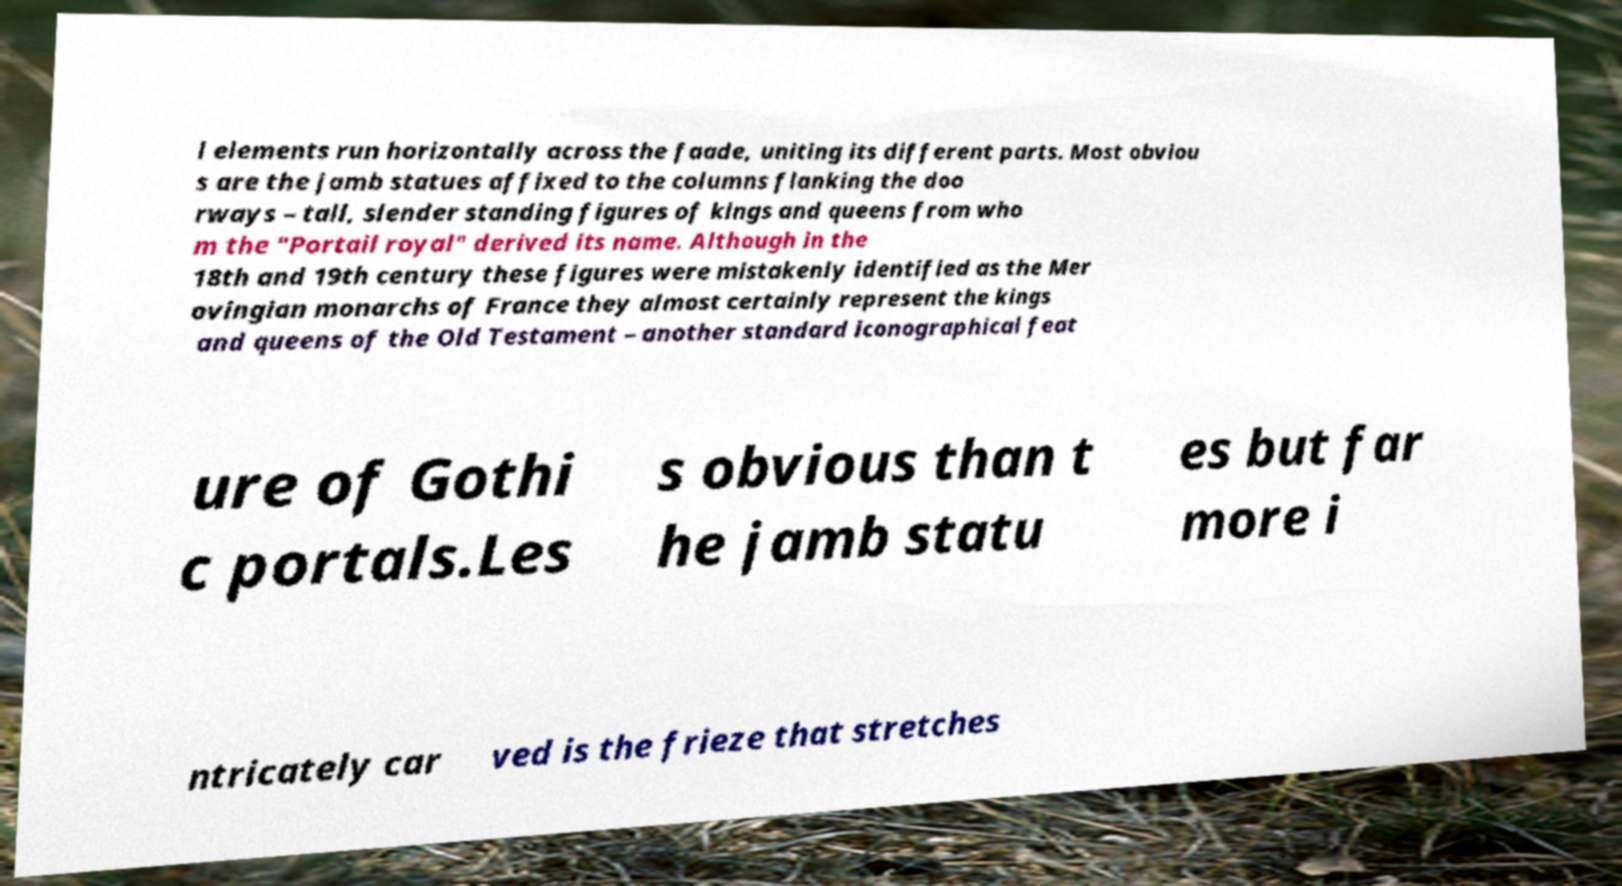Can you accurately transcribe the text from the provided image for me? l elements run horizontally across the faade, uniting its different parts. Most obviou s are the jamb statues affixed to the columns flanking the doo rways – tall, slender standing figures of kings and queens from who m the "Portail royal" derived its name. Although in the 18th and 19th century these figures were mistakenly identified as the Mer ovingian monarchs of France they almost certainly represent the kings and queens of the Old Testament – another standard iconographical feat ure of Gothi c portals.Les s obvious than t he jamb statu es but far more i ntricately car ved is the frieze that stretches 